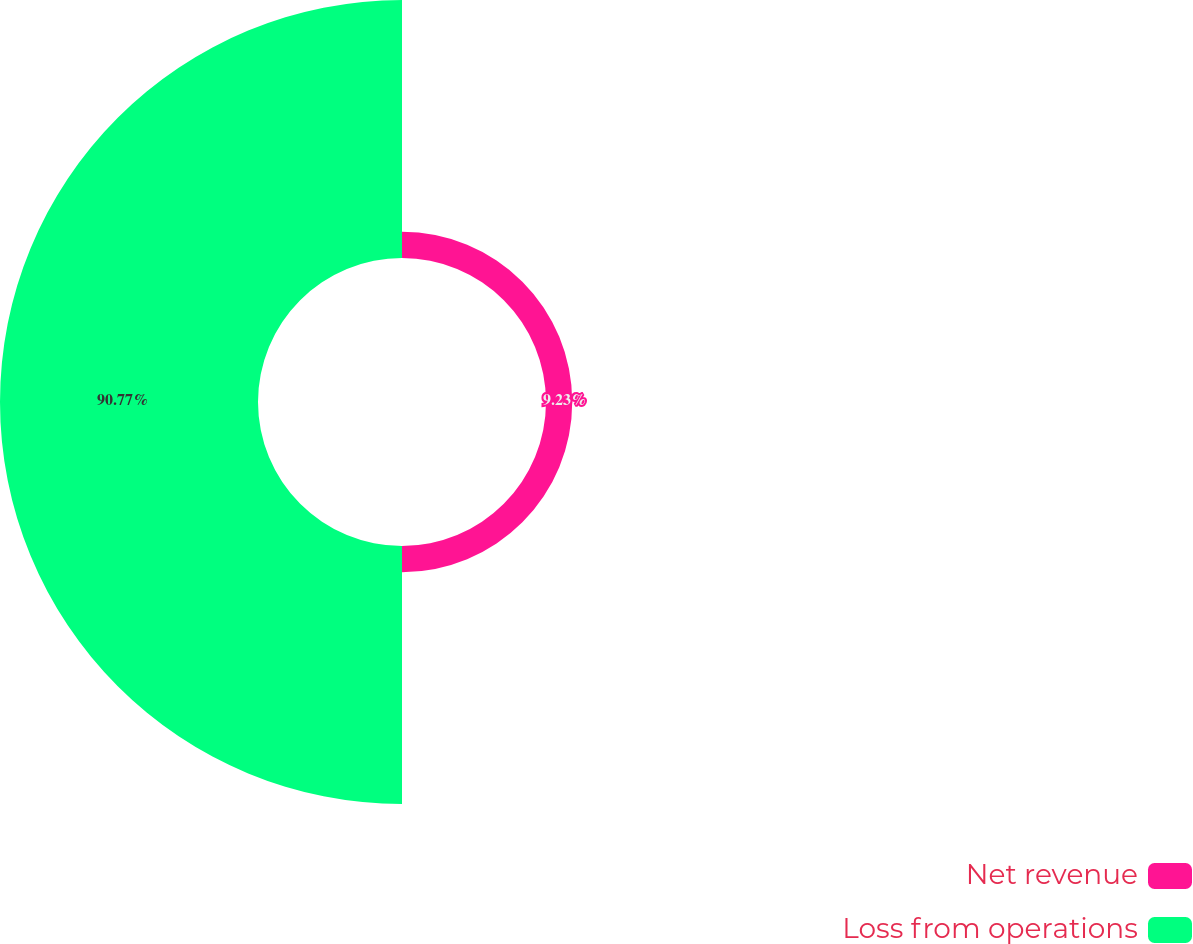Convert chart. <chart><loc_0><loc_0><loc_500><loc_500><pie_chart><fcel>Net revenue<fcel>Loss from operations<nl><fcel>9.23%<fcel>90.77%<nl></chart> 